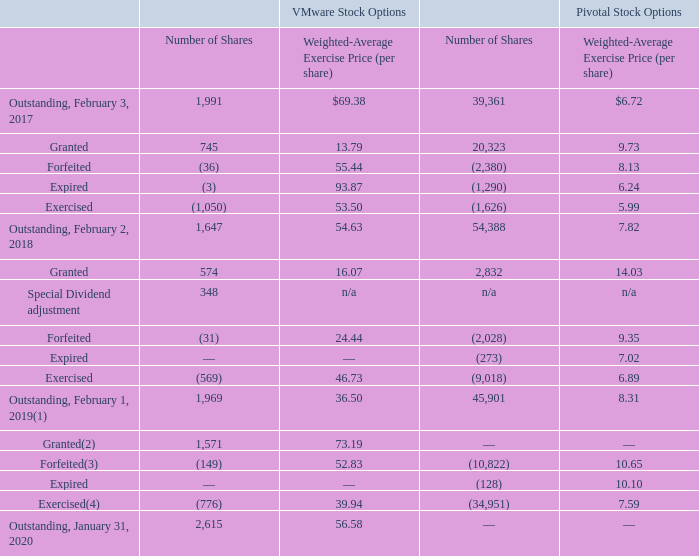VMware and Pivotal Stock Options
The following table summarizes stock option activity for VMware and Pivotal since February 3, 2017 (shares in thousands):
(1) The weighted-average exercise price of options outstanding as of February 1, 2019 reflects the adjustments to the options as a result of the Special Dividend.
(2) Stock option granted under the VMware equity plan includes 0.6 million options issued for unvested options assumed as part of the Pivotal acquisition.
(3) Stock options forfeited under the Pivotal equity plan includes 6.2 million options converted to VMware options as part of the Pivotal acquisition, using a conversion ratio of 0.1.
(4) Stock options exercised under the Pivotal equity plan includes 22.4 million of vested options that were settled in cash as part of the Pivotal acquisition.
The above table includes stock options granted in conjunction with unvested stock options assumed in business combinations. As a result, the weighted-average exercise price per share may vary from the VMware stock price at time of grant
The stock options outstanding as of January 31, 2020 had an aggregate intrinsic value of $239 million based on VMware’s closing stock price as of January 31, 2020.
What were the stock options outstanding value as of January 31, 2020? Aggregate intrinsic value of $239 million based on vmware’s closing stock price as of january 31, 2020. What was the outstanding number of shares for VMware stock options in 2017?
Answer scale should be: thousand. 1,991. What was the number of granted shares from Pivotal Stock Options in 2018?
Answer scale should be: thousand. 2,832. What was the change in outstanding number of shares for VMware Stock Options between 2017 and 2018?
Answer scale should be: thousand. 1,647-1,991
Answer: -344. How many years did the outstanding Weighted-Average Exercise Price (per share) for VMware stock options exceed $60.00? 2017
Answer: 1. What was the percentage change in the outstanding weighted-average exercise price per share for pivotal stock options between 2018 and 2019?
Answer scale should be: percent. (8.31-7.82)/7.82
Answer: 6.27. 